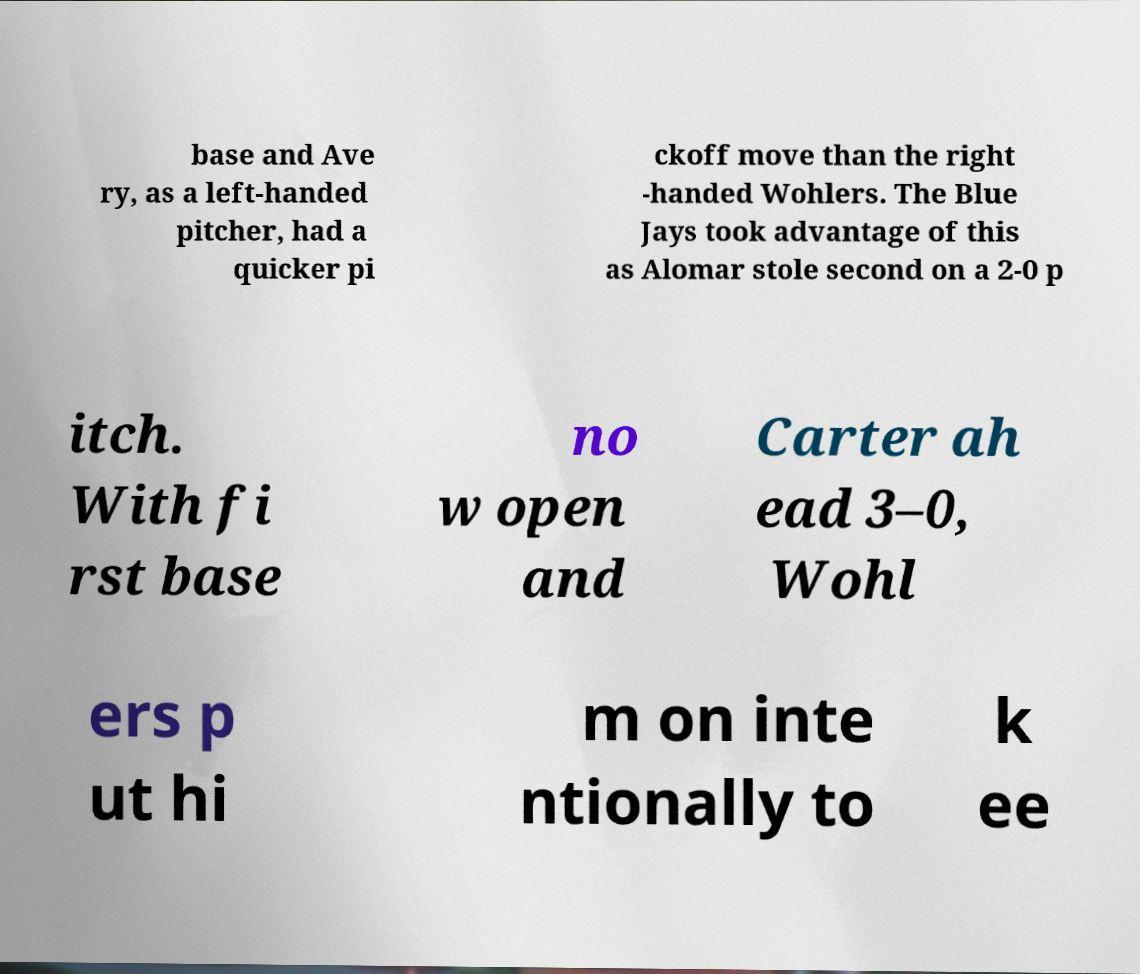For documentation purposes, I need the text within this image transcribed. Could you provide that? base and Ave ry, as a left-handed pitcher, had a quicker pi ckoff move than the right -handed Wohlers. The Blue Jays took advantage of this as Alomar stole second on a 2-0 p itch. With fi rst base no w open and Carter ah ead 3–0, Wohl ers p ut hi m on inte ntionally to k ee 